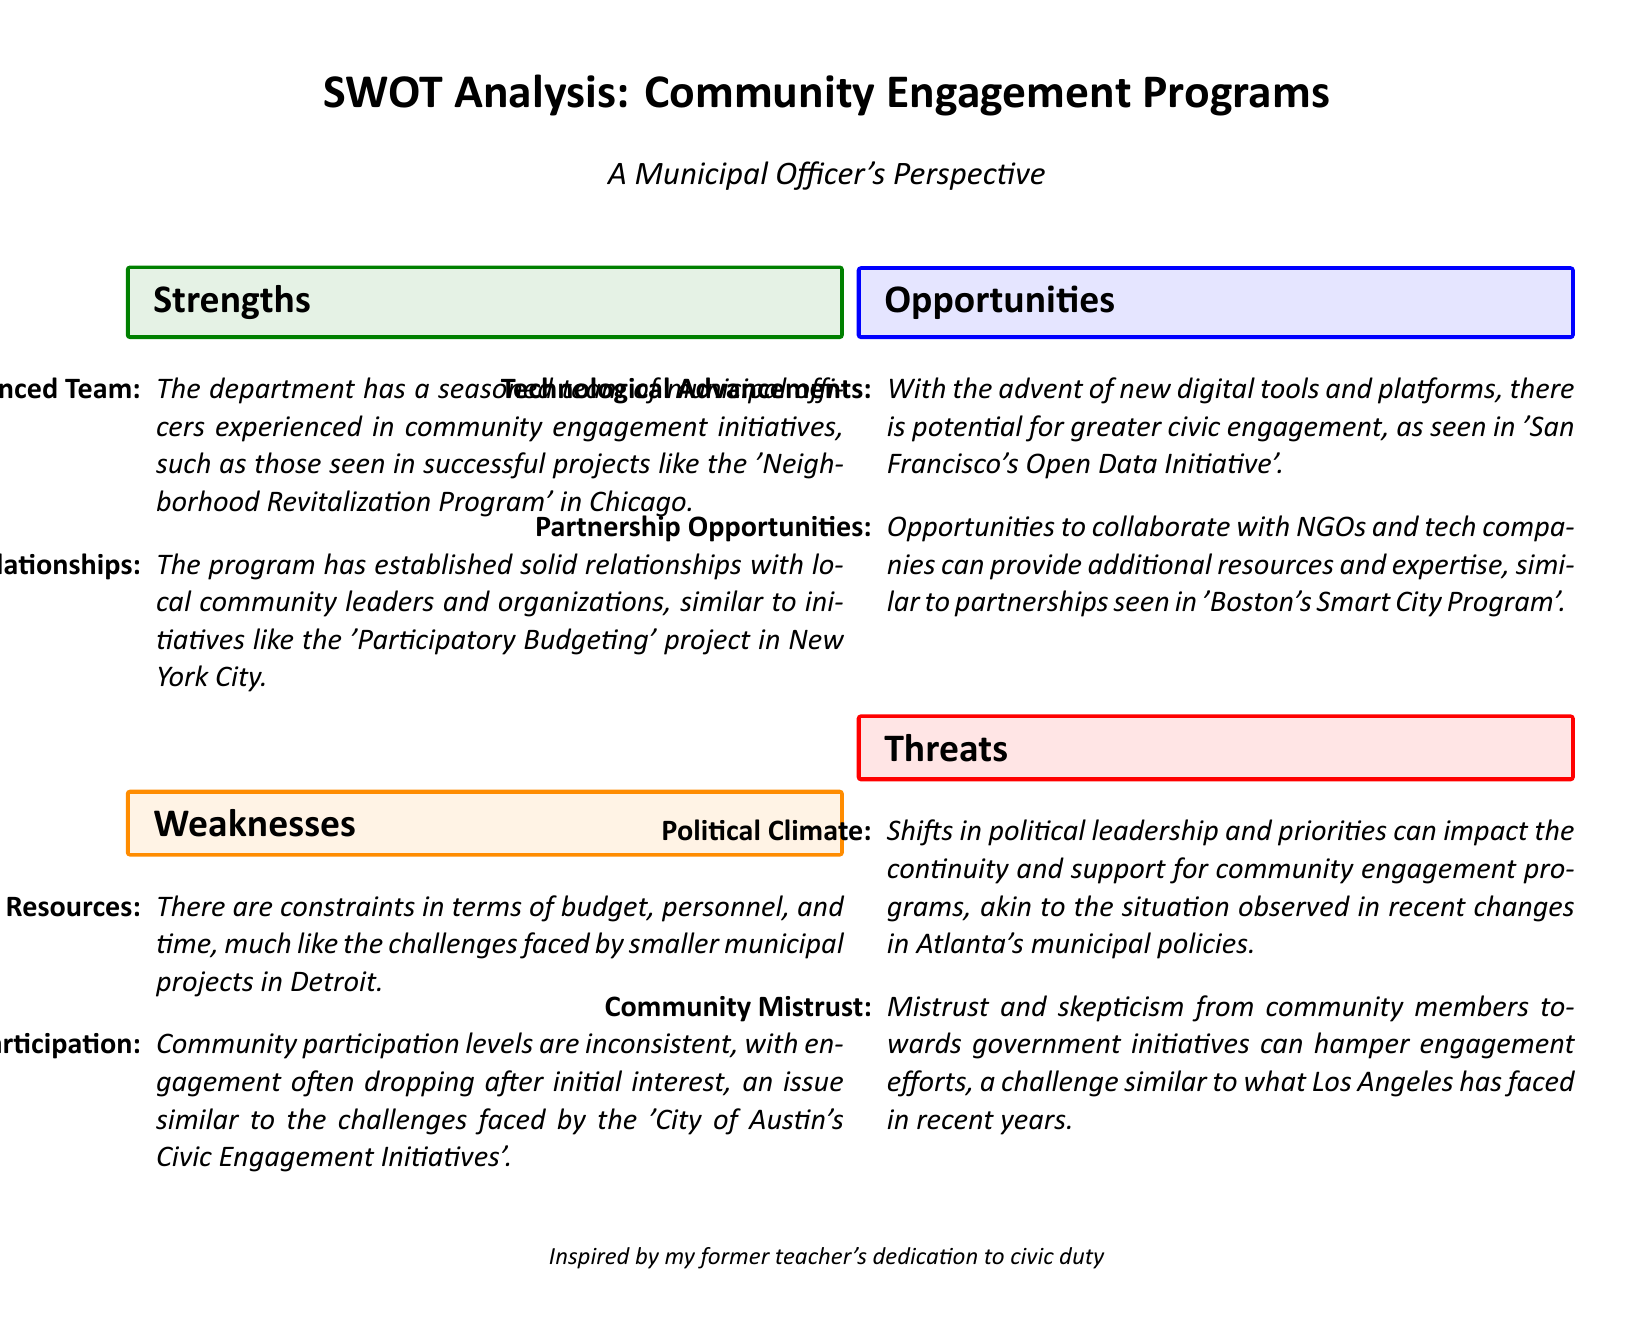What are the strengths of the community engagement program? The strengths are listed as "Experienced Team" and "Strong Community Relationships."
Answer: Experienced Team, Strong Community Relationships What weaknesses does the document identify in community engagement programs? The weaknesses mentioned are "Limited Resources" and "Inconsistent Participation."
Answer: Limited Resources, Inconsistent Participation Which city is mentioned in relation to strong community relationships? The document cites the "Participatory Budgeting" project in New York City to illustrate strong community relationships.
Answer: New York City What opportunity related to technological advancements is highlighted? The document notes the "advent of new digital tools and platforms" as an opportunity for greater civic engagement.
Answer: New digital tools and platforms What threat does the document associate with shifts in political leadership? The threat specified is that shifts can impact "continuity and support for community engagement programs."
Answer: Continuity and support impact How many strengths are outlined in the SWOT analysis? The SWOT analysis includes two strengths listed under the strengths section.
Answer: 2 Name one opportunity for collaboration mentioned in the document. The document mentions "Partnership Opportunities" as a potential collaborative area.
Answer: Partnership Opportunities What is a key factor that threatens civic engagement according to the document? The document states "Community Mistrust" as a key factor that threatens civic engagement programs.
Answer: Community Mistrust What perspective is the SWOT analysis written from? It is written from a "Municipal Officer's Perspective."
Answer: Municipal Officer's Perspective 